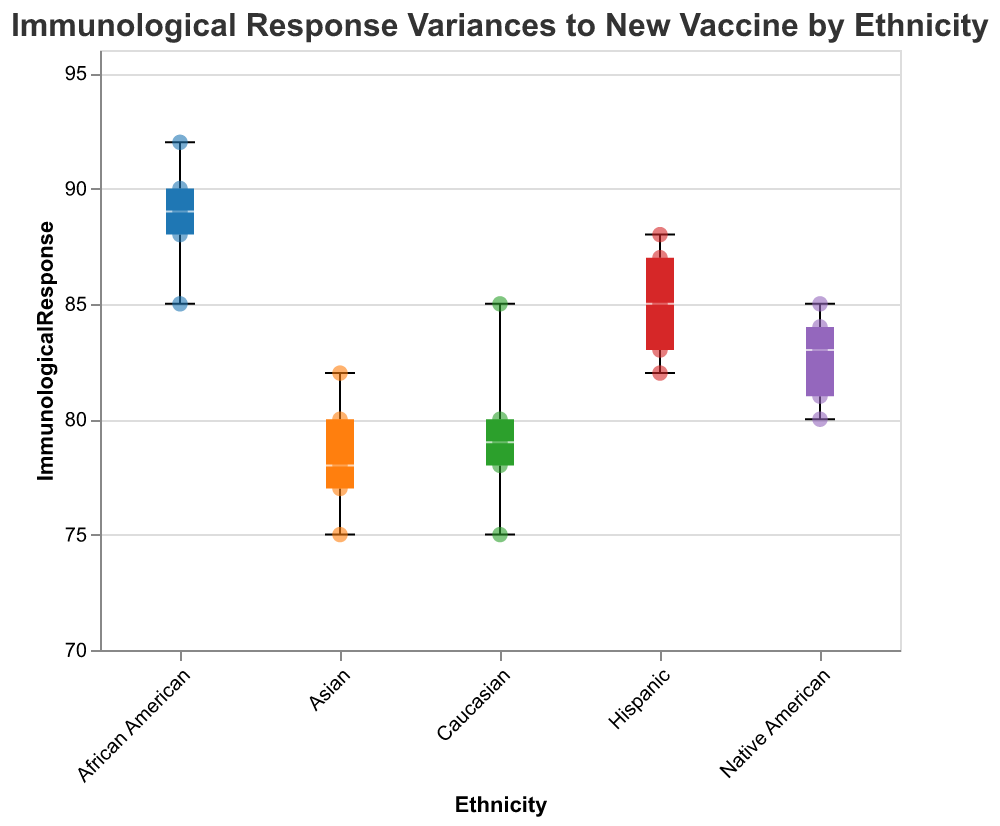How many distinct ethnic groups are depicted in the figure? The figure includes distinct ethnic groups represented by different colors. By counting these groups, we determine the total number.
Answer: 5 Which ethnicity has the highest median immunological response? To find the highest median value, we look at the central horizontal lines within each box plot. The highest median line visually corresponds to the African American group.
Answer: African American What's the range of immunological responses in the Asian group? The range is determined by finding the difference between the maximum and minimum values in the box plot for the Asian group. The maximum value is 82, and the minimum value is 75. Hence, the range is 82 - 75.
Answer: 7 Which ethnic group shows the most variability in immunological response? Variability is shown by the length of the box plot. The African American group's long box plot indicates the most variability.
Answer: African American What is the minimum immunological response observed among Native American individuals? The minimum value can be observed from the lower whisker of the box plot for the Native American group. This whisker extends down to the minimum observed value, which is 80.
Answer: 80 How many individual data points are there for the Hispanic ethnicity? Counting the scatter points in the Hispanic section, we see they add up to 5.
Answer: 5 Compare the range of immunological responses between Caucasian and Hispanic groups. Which is larger? The range for each group is determined by the difference between their respective maximum and minimum values in the box plots. For the Caucasian group, the range is 85 - 75 = 10; for the Hispanic group, the range is 88 - 82 = 6. A comparison shows the Caucasian group's range is larger.
Answer: Caucasian Is the median immunological response for the Hispanic group higher or lower than that for the Asian group? The median values are indicated by the central lines within the box plots. The median for the Hispanic group is higher than that for the Asian group based on the vertical positioning.
Answer: Higher Which ethnic group has the least variability in their immunological response? The group with the smallest box plot indicates the least variability. The Asian group's short box plot reflects minimal variability.
Answer: Asian 